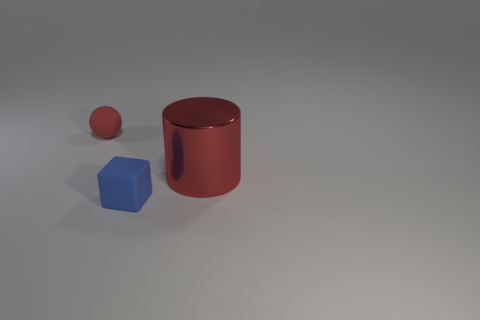Is there anything else that is the same material as the big thing?
Ensure brevity in your answer.  No. There is a big metal thing that is the same color as the sphere; what shape is it?
Your response must be concise. Cylinder. What size is the cube?
Ensure brevity in your answer.  Small. Is the material of the big cylinder the same as the small block?
Provide a short and direct response. No. There is a red shiny cylinder that is behind the tiny rubber object right of the small matte sphere; how many balls are to the right of it?
Give a very brief answer. 0. What is the shape of the red object that is to the left of the small block?
Offer a very short reply. Sphere. What number of other things are the same material as the large object?
Keep it short and to the point. 0. Do the tiny matte block and the matte sphere have the same color?
Offer a terse response. No. Are there fewer large red things on the left side of the metal cylinder than rubber cubes that are on the left side of the tiny blue thing?
Provide a succinct answer. No. Is the size of the rubber thing to the right of the red rubber ball the same as the small red ball?
Ensure brevity in your answer.  Yes. 